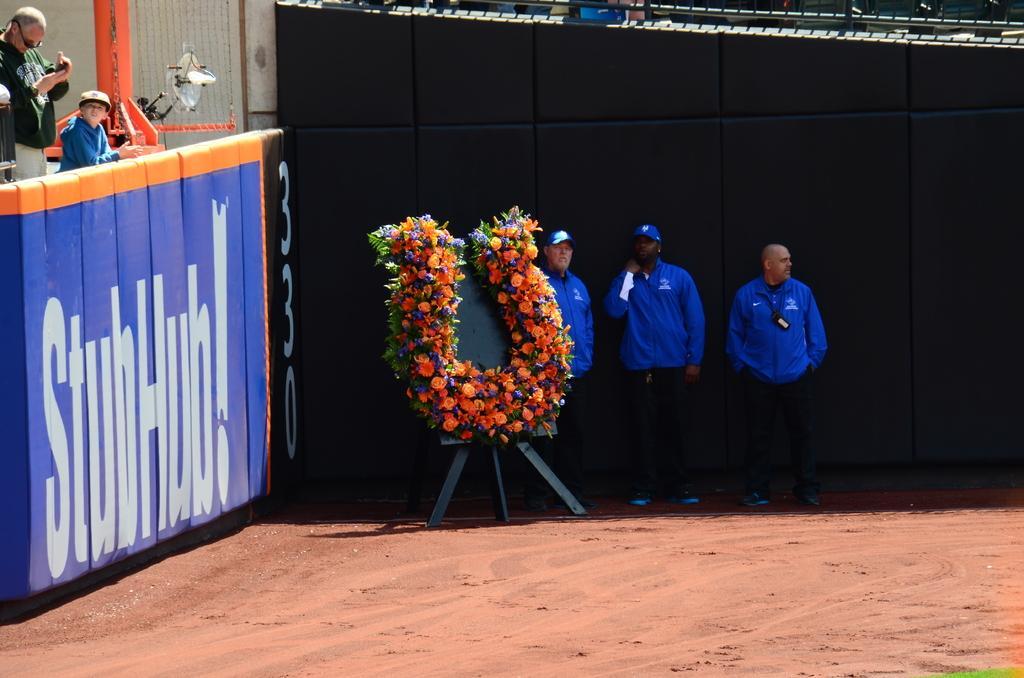How would you summarize this image in a sentence or two? In the image in the center we can see board,flower garland and three persons were standing and they were in blue color jacket. On the left side of the image we can see two persons standing and holding some objects. In the background we can see fence,banner,wall,pole and few other objects. 